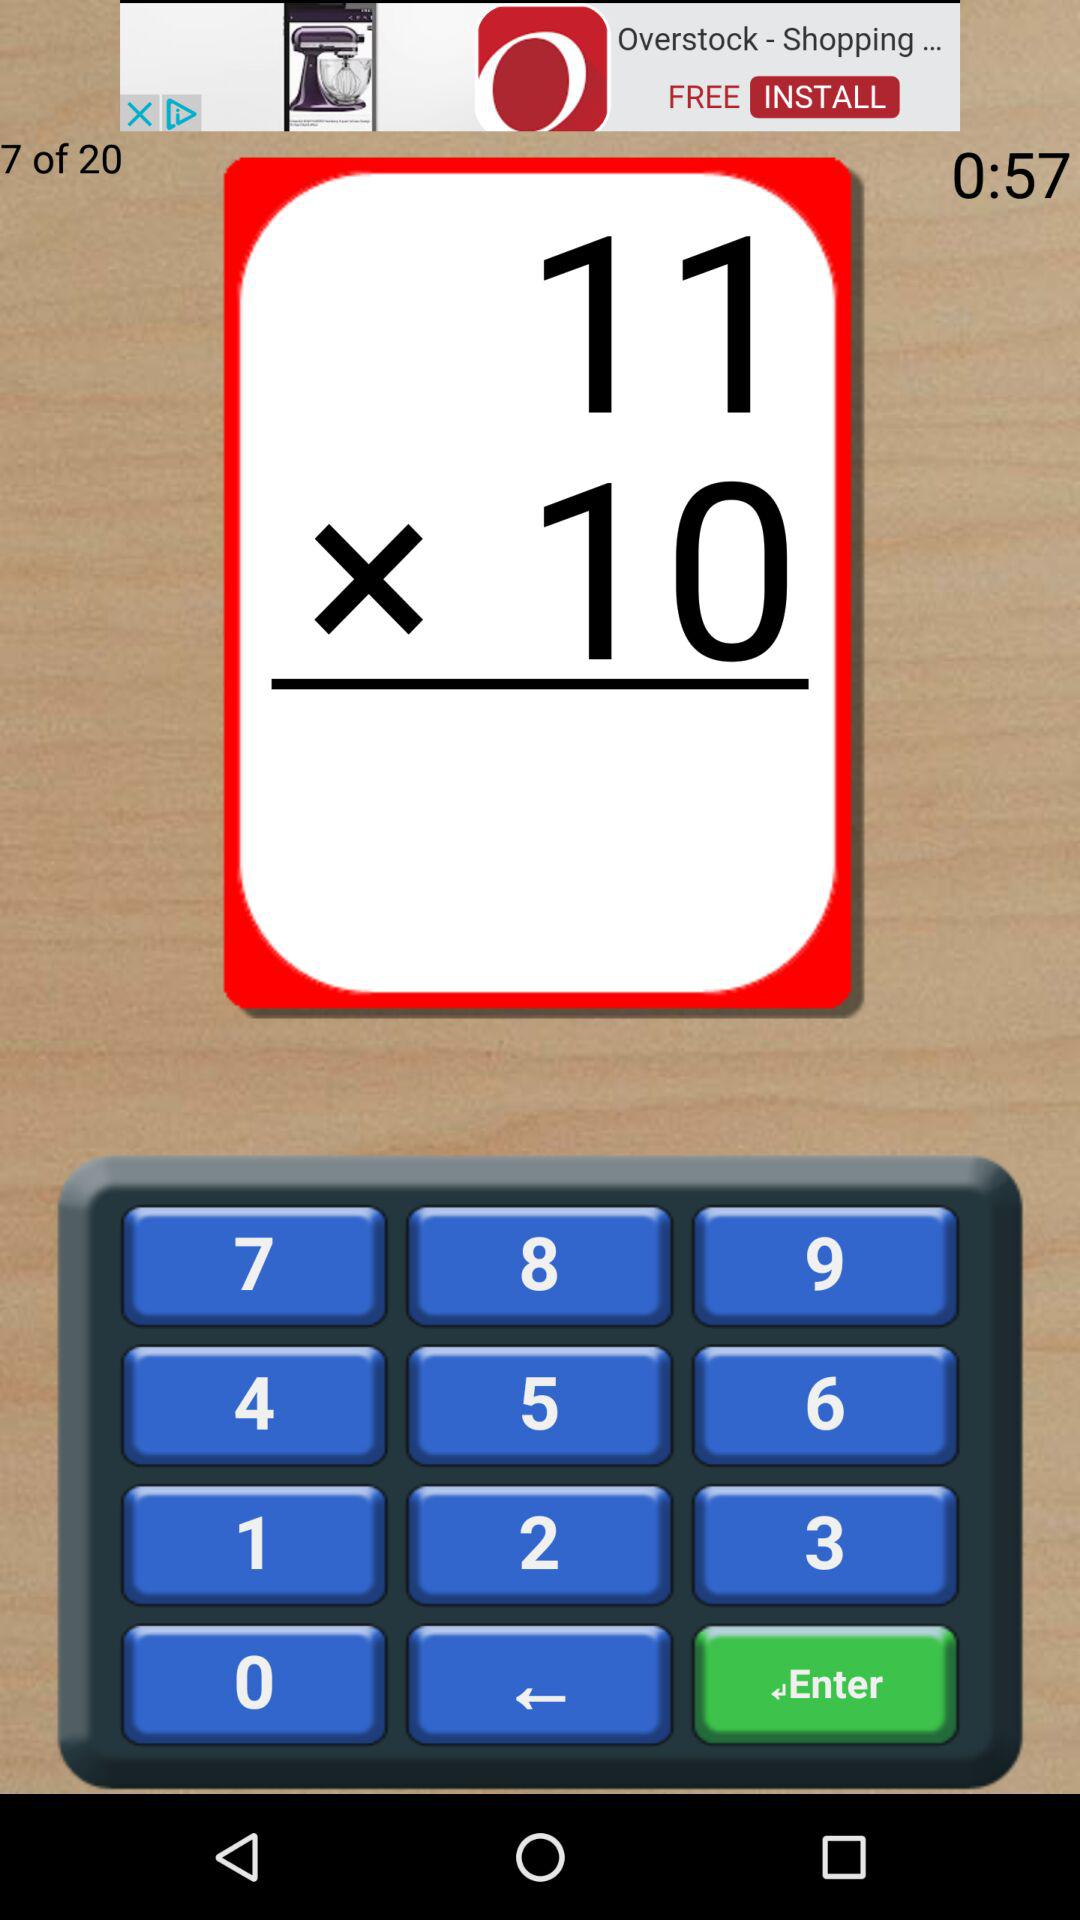How much time is remaining? The remaining time is 57 seconds. 